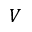<formula> <loc_0><loc_0><loc_500><loc_500>V</formula> 